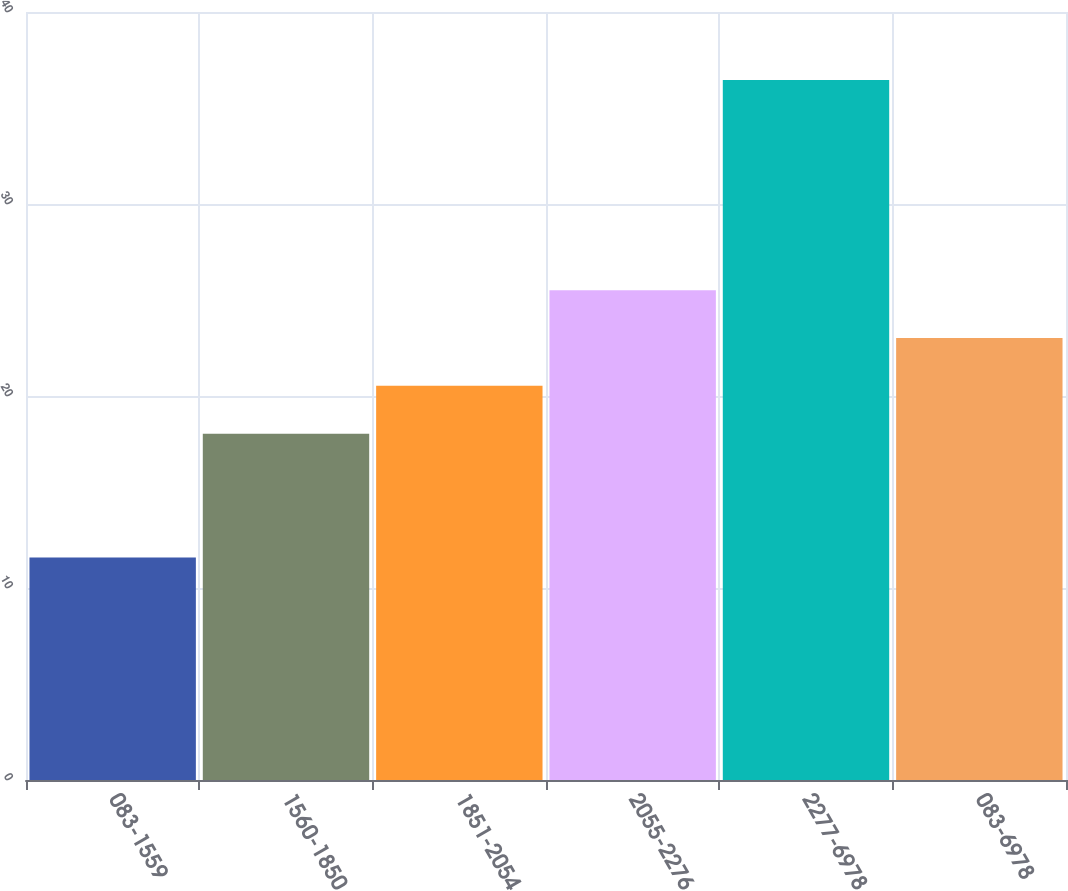<chart> <loc_0><loc_0><loc_500><loc_500><bar_chart><fcel>083-1559<fcel>1560-1850<fcel>1851-2054<fcel>2055-2276<fcel>2277-6978<fcel>083-6978<nl><fcel>11.59<fcel>18.04<fcel>20.53<fcel>25.51<fcel>36.46<fcel>23.02<nl></chart> 